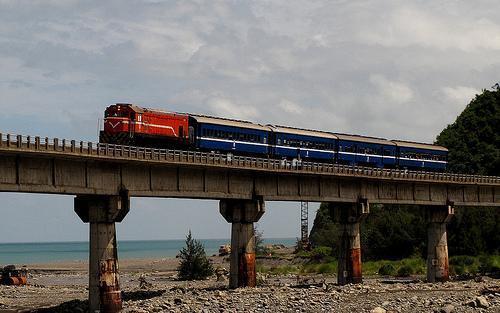How many trains are there?
Give a very brief answer. 1. 